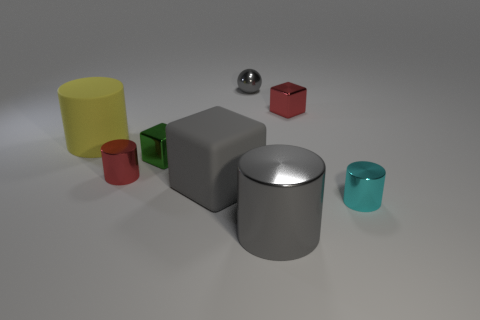How many other things are there of the same size as the gray matte block?
Keep it short and to the point. 2. How many blue things are either tiny cubes or small balls?
Offer a terse response. 0. How many metal objects are behind the green metallic block and right of the tiny gray sphere?
Ensure brevity in your answer.  1. The small red thing behind the large yellow cylinder behind the tiny shiny object to the left of the small green metal thing is made of what material?
Give a very brief answer. Metal. How many tiny cubes have the same material as the tiny cyan cylinder?
Offer a terse response. 2. What is the shape of the small metal object that is the same color as the big cube?
Your answer should be very brief. Sphere. There is a gray rubber object that is the same size as the yellow rubber cylinder; what shape is it?
Provide a succinct answer. Cube. There is a big cube that is the same color as the tiny metallic sphere; what is it made of?
Your answer should be very brief. Rubber. There is a large yellow object; are there any red shiny objects in front of it?
Your answer should be very brief. Yes. Are there any small things of the same shape as the big gray metal thing?
Your answer should be very brief. Yes. 